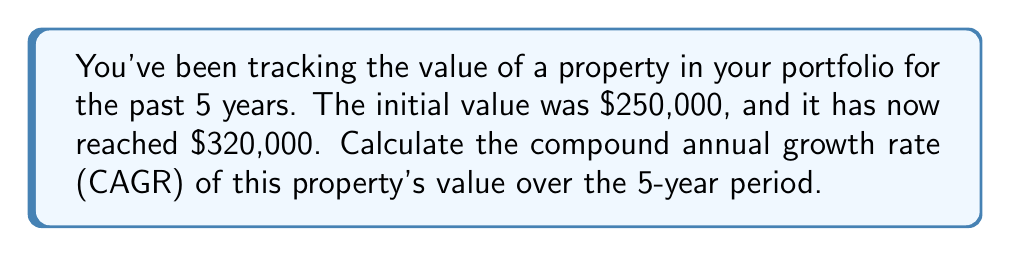Solve this math problem. To calculate the Compound Annual Growth Rate (CAGR), we use the following formula:

$$ CAGR = \left(\frac{Ending Value}{Beginning Value}\right)^{\frac{1}{n}} - 1 $$

Where:
- Ending Value = $320,000
- Beginning Value = $250,000
- n = number of years = 5

Let's substitute these values into the formula:

$$ CAGR = \left(\frac{320,000}{250,000}\right)^{\frac{1}{5}} - 1 $$

$$ CAGR = (1.28)^{\frac{1}{5}} - 1 $$

Now, let's calculate the fifth root of 1.28:

$$ CAGR = 1.0506 - 1 $$

$$ CAGR = 0.0506 $$

To convert this to a percentage, we multiply by 100:

$$ CAGR = 0.0506 \times 100 = 5.06\% $$
Answer: 5.06% 